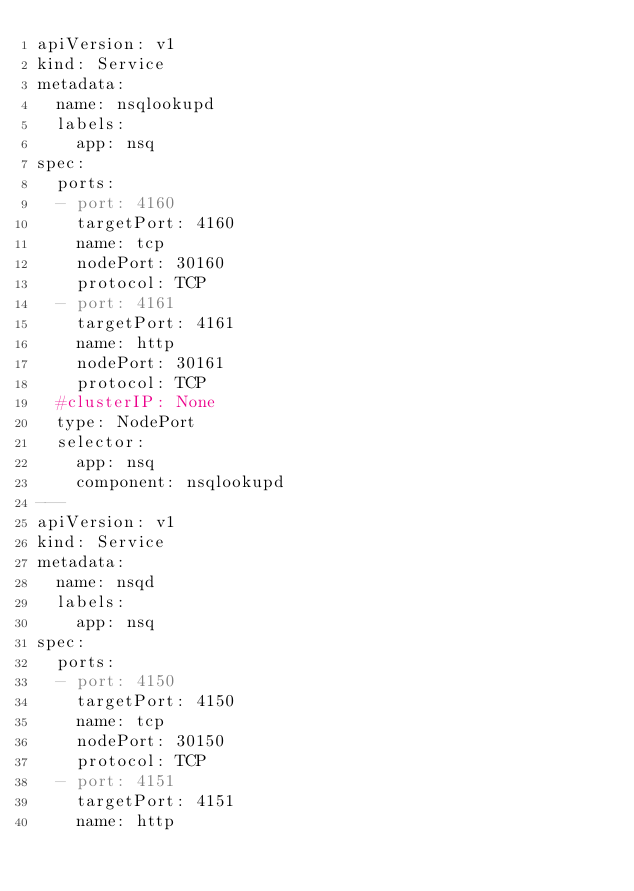Convert code to text. <code><loc_0><loc_0><loc_500><loc_500><_YAML_>apiVersion: v1
kind: Service
metadata:
  name: nsqlookupd
  labels:
    app: nsq
spec:
  ports:
  - port: 4160
    targetPort: 4160
    name: tcp
    nodePort: 30160
    protocol: TCP
  - port: 4161
    targetPort: 4161
    name: http
    nodePort: 30161
    protocol: TCP
  #clusterIP: None
  type: NodePort
  selector:
    app: nsq
    component: nsqlookupd
---
apiVersion: v1
kind: Service
metadata:
  name: nsqd
  labels:
    app: nsq
spec:
  ports:
  - port: 4150
    targetPort: 4150
    name: tcp
    nodePort: 30150
    protocol: TCP
  - port: 4151
    targetPort: 4151
    name: http</code> 